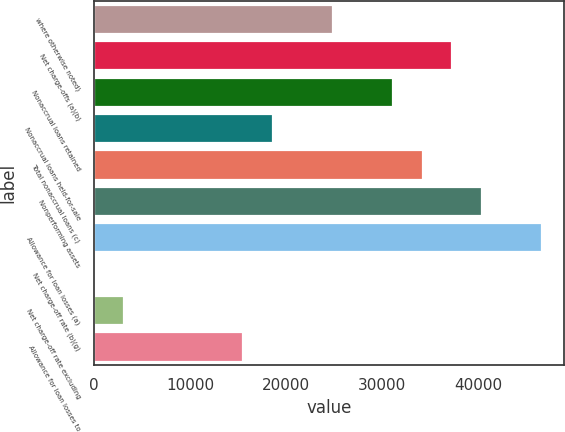Convert chart. <chart><loc_0><loc_0><loc_500><loc_500><bar_chart><fcel>where otherwise noted)<fcel>Net charge-offs (a)(b)<fcel>Nonaccrual loans retained<fcel>Nonaccrual loans held-for-sale<fcel>Total nonaccrual loans (c)<fcel>Nonperforming assets<fcel>Allowance for loan losses (a)<fcel>Net charge-off rate (b)(g)<fcel>Net charge-off rate excluding<fcel>Allowance for loan losses to<nl><fcel>24891.6<fcel>37336.3<fcel>31114<fcel>18669.3<fcel>34225.1<fcel>40447.5<fcel>46669.8<fcel>2.27<fcel>3113.44<fcel>15558.1<nl></chart> 